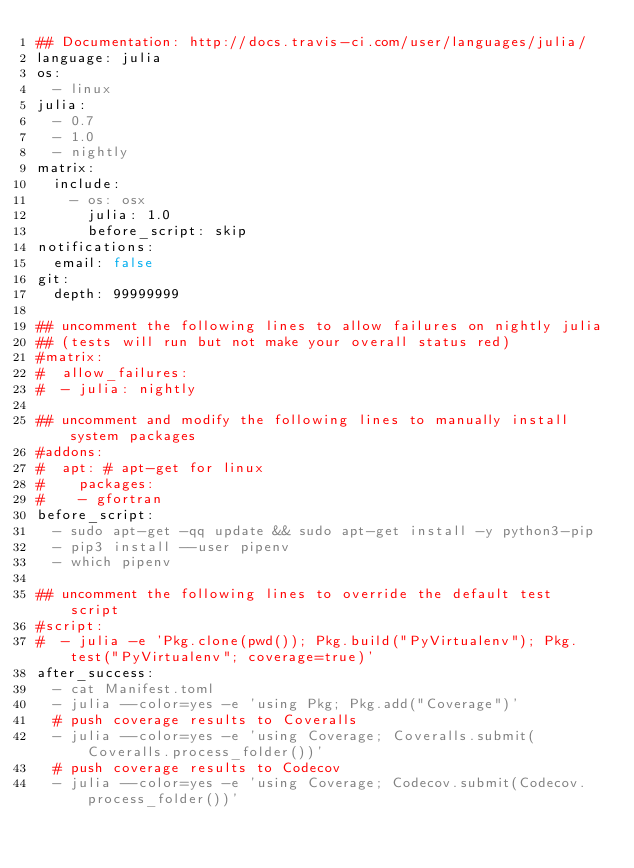Convert code to text. <code><loc_0><loc_0><loc_500><loc_500><_YAML_>## Documentation: http://docs.travis-ci.com/user/languages/julia/
language: julia
os:
  - linux
julia:
  - 0.7
  - 1.0
  - nightly
matrix:
  include:
    - os: osx
      julia: 1.0
      before_script: skip
notifications:
  email: false
git:
  depth: 99999999

## uncomment the following lines to allow failures on nightly julia
## (tests will run but not make your overall status red)
#matrix:
#  allow_failures:
#  - julia: nightly

## uncomment and modify the following lines to manually install system packages
#addons:
#  apt: # apt-get for linux
#    packages:
#    - gfortran
before_script:
  - sudo apt-get -qq update && sudo apt-get install -y python3-pip
  - pip3 install --user pipenv
  - which pipenv

## uncomment the following lines to override the default test script
#script:
#  - julia -e 'Pkg.clone(pwd()); Pkg.build("PyVirtualenv"); Pkg.test("PyVirtualenv"; coverage=true)'
after_success:
  - cat Manifest.toml
  - julia --color=yes -e 'using Pkg; Pkg.add("Coverage")'
  # push coverage results to Coveralls
  - julia --color=yes -e 'using Coverage; Coveralls.submit(Coveralls.process_folder())'
  # push coverage results to Codecov
  - julia --color=yes -e 'using Coverage; Codecov.submit(Codecov.process_folder())'
</code> 